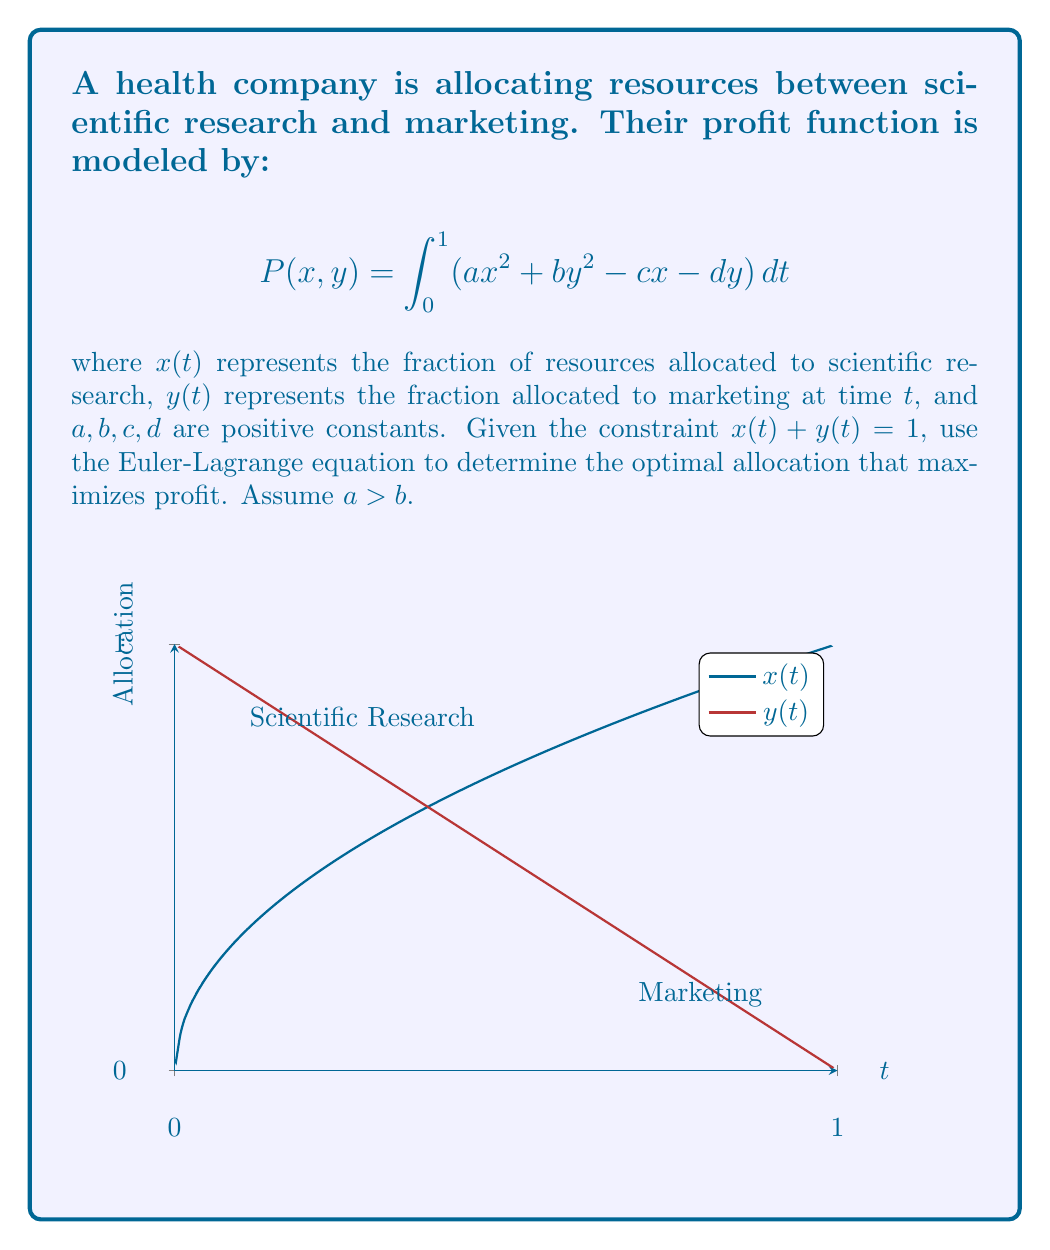Can you answer this question? 1) First, we formulate the problem using the calculus of variations. Our functional is:

   $$J[x,y] = \int_0^1 (ax^2 + by^2 - cx - dy) dt$$

   subject to the constraint $x + y = 1$ or $y = 1 - x$.

2) Substituting the constraint into our functional:

   $$J[x] = \int_0^1 (ax^2 + b(1-x)^2 - cx - d(1-x)) dt$$

3) Expanding this:

   $$J[x] = \int_0^1 (ax^2 + b - 2bx + bx^2 - cx - d + dx) dt$$
   $$= \int_0^1 ((a+b)x^2 + (d-c-2b)x + (b-d)) dt$$

4) Now we can apply the Euler-Lagrange equation. For a functional of the form:

   $$J[x] = \int_a^b F(t, x, x') dt$$

   The Euler-Lagrange equation is:

   $$\frac{\partial F}{\partial x} - \frac{d}{dt}\frac{\partial F}{\partial x'} = 0$$

5) In our case, $F = (a+b)x^2 + (d-c-2b)x + (b-d)$, and it doesn't depend on $x'$, so:

   $$\frac{\partial F}{\partial x} = 2(a+b)x + (d-c-2b) = 0$$

6) Solving for x:

   $$x = \frac{c+2b-d}{2(a+b)}$$

7) Given that $a > b$, this solution will always be between 0 and 1. The optimal allocation for marketing, $y$, is then:

   $$y = 1 - x = 1 - \frac{c+2b-d}{2(a+b)} = \frac{2a+2b-c-2b+d}{2(a+b)} = \frac{2a-c+d}{2(a+b)}$$

8) This solution shows that when $a > b$, more resources should be allocated to scientific research than marketing, aligning with the skeptical persona regarding celebrity-driven health advice and marketing.
Answer: $x = \frac{c+2b-d}{2(a+b)}$, $y = \frac{2a-c+d}{2(a+b)}$ 